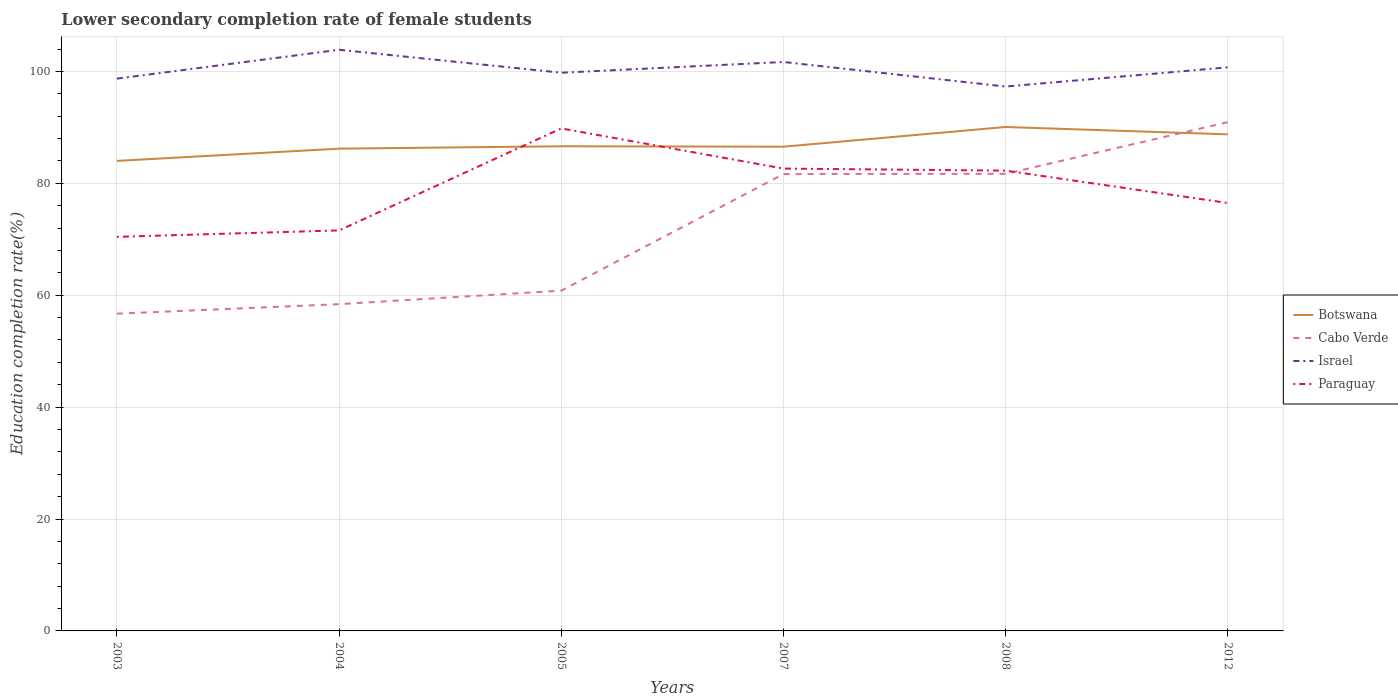How many different coloured lines are there?
Make the answer very short. 4. Does the line corresponding to Paraguay intersect with the line corresponding to Botswana?
Give a very brief answer. Yes. Across all years, what is the maximum lower secondary completion rate of female students in Cabo Verde?
Your answer should be compact. 56.7. What is the total lower secondary completion rate of female students in Botswana in the graph?
Offer a terse response. 1.32. What is the difference between the highest and the second highest lower secondary completion rate of female students in Paraguay?
Keep it short and to the point. 19.38. What is the difference between the highest and the lowest lower secondary completion rate of female students in Cabo Verde?
Offer a terse response. 3. Is the lower secondary completion rate of female students in Israel strictly greater than the lower secondary completion rate of female students in Cabo Verde over the years?
Offer a very short reply. No. How many lines are there?
Ensure brevity in your answer.  4. How many years are there in the graph?
Offer a very short reply. 6. Does the graph contain any zero values?
Ensure brevity in your answer.  No. Does the graph contain grids?
Provide a short and direct response. Yes. What is the title of the graph?
Provide a succinct answer. Lower secondary completion rate of female students. Does "Angola" appear as one of the legend labels in the graph?
Provide a succinct answer. No. What is the label or title of the Y-axis?
Provide a short and direct response. Education completion rate(%). What is the Education completion rate(%) in Botswana in 2003?
Your response must be concise. 84.01. What is the Education completion rate(%) in Cabo Verde in 2003?
Offer a very short reply. 56.7. What is the Education completion rate(%) of Israel in 2003?
Make the answer very short. 98.71. What is the Education completion rate(%) of Paraguay in 2003?
Your answer should be very brief. 70.43. What is the Education completion rate(%) in Botswana in 2004?
Ensure brevity in your answer.  86.19. What is the Education completion rate(%) in Cabo Verde in 2004?
Offer a very short reply. 58.4. What is the Education completion rate(%) in Israel in 2004?
Offer a terse response. 103.87. What is the Education completion rate(%) in Paraguay in 2004?
Provide a succinct answer. 71.58. What is the Education completion rate(%) of Botswana in 2005?
Your answer should be very brief. 86.62. What is the Education completion rate(%) of Cabo Verde in 2005?
Your response must be concise. 60.82. What is the Education completion rate(%) of Israel in 2005?
Offer a terse response. 99.77. What is the Education completion rate(%) of Paraguay in 2005?
Provide a short and direct response. 89.81. What is the Education completion rate(%) in Botswana in 2007?
Provide a short and direct response. 86.54. What is the Education completion rate(%) in Cabo Verde in 2007?
Keep it short and to the point. 81.65. What is the Education completion rate(%) in Israel in 2007?
Your response must be concise. 101.68. What is the Education completion rate(%) of Paraguay in 2007?
Give a very brief answer. 82.63. What is the Education completion rate(%) of Botswana in 2008?
Offer a terse response. 90.06. What is the Education completion rate(%) of Cabo Verde in 2008?
Make the answer very short. 81.7. What is the Education completion rate(%) of Israel in 2008?
Your answer should be very brief. 97.29. What is the Education completion rate(%) in Paraguay in 2008?
Offer a terse response. 82.26. What is the Education completion rate(%) in Botswana in 2012?
Provide a succinct answer. 88.75. What is the Education completion rate(%) of Cabo Verde in 2012?
Keep it short and to the point. 90.93. What is the Education completion rate(%) in Israel in 2012?
Keep it short and to the point. 100.73. What is the Education completion rate(%) of Paraguay in 2012?
Your response must be concise. 76.48. Across all years, what is the maximum Education completion rate(%) in Botswana?
Offer a terse response. 90.06. Across all years, what is the maximum Education completion rate(%) of Cabo Verde?
Give a very brief answer. 90.93. Across all years, what is the maximum Education completion rate(%) in Israel?
Keep it short and to the point. 103.87. Across all years, what is the maximum Education completion rate(%) in Paraguay?
Offer a terse response. 89.81. Across all years, what is the minimum Education completion rate(%) in Botswana?
Your response must be concise. 84.01. Across all years, what is the minimum Education completion rate(%) of Cabo Verde?
Provide a short and direct response. 56.7. Across all years, what is the minimum Education completion rate(%) in Israel?
Give a very brief answer. 97.29. Across all years, what is the minimum Education completion rate(%) in Paraguay?
Offer a very short reply. 70.43. What is the total Education completion rate(%) of Botswana in the graph?
Give a very brief answer. 522.17. What is the total Education completion rate(%) in Cabo Verde in the graph?
Your answer should be compact. 430.19. What is the total Education completion rate(%) of Israel in the graph?
Your answer should be compact. 602.05. What is the total Education completion rate(%) in Paraguay in the graph?
Your response must be concise. 473.21. What is the difference between the Education completion rate(%) in Botswana in 2003 and that in 2004?
Make the answer very short. -2.19. What is the difference between the Education completion rate(%) of Cabo Verde in 2003 and that in 2004?
Make the answer very short. -1.7. What is the difference between the Education completion rate(%) in Israel in 2003 and that in 2004?
Offer a terse response. -5.16. What is the difference between the Education completion rate(%) of Paraguay in 2003 and that in 2004?
Offer a very short reply. -1.15. What is the difference between the Education completion rate(%) in Botswana in 2003 and that in 2005?
Your answer should be very brief. -2.62. What is the difference between the Education completion rate(%) of Cabo Verde in 2003 and that in 2005?
Offer a terse response. -4.12. What is the difference between the Education completion rate(%) in Israel in 2003 and that in 2005?
Your answer should be very brief. -1.05. What is the difference between the Education completion rate(%) in Paraguay in 2003 and that in 2005?
Your answer should be compact. -19.38. What is the difference between the Education completion rate(%) of Botswana in 2003 and that in 2007?
Keep it short and to the point. -2.54. What is the difference between the Education completion rate(%) in Cabo Verde in 2003 and that in 2007?
Keep it short and to the point. -24.95. What is the difference between the Education completion rate(%) of Israel in 2003 and that in 2007?
Offer a terse response. -2.97. What is the difference between the Education completion rate(%) of Paraguay in 2003 and that in 2007?
Your answer should be compact. -12.2. What is the difference between the Education completion rate(%) of Botswana in 2003 and that in 2008?
Give a very brief answer. -6.06. What is the difference between the Education completion rate(%) in Cabo Verde in 2003 and that in 2008?
Your response must be concise. -25. What is the difference between the Education completion rate(%) of Israel in 2003 and that in 2008?
Keep it short and to the point. 1.42. What is the difference between the Education completion rate(%) in Paraguay in 2003 and that in 2008?
Offer a terse response. -11.83. What is the difference between the Education completion rate(%) in Botswana in 2003 and that in 2012?
Your response must be concise. -4.74. What is the difference between the Education completion rate(%) in Cabo Verde in 2003 and that in 2012?
Offer a terse response. -34.23. What is the difference between the Education completion rate(%) in Israel in 2003 and that in 2012?
Offer a very short reply. -2.02. What is the difference between the Education completion rate(%) in Paraguay in 2003 and that in 2012?
Your answer should be compact. -6.05. What is the difference between the Education completion rate(%) of Botswana in 2004 and that in 2005?
Keep it short and to the point. -0.43. What is the difference between the Education completion rate(%) in Cabo Verde in 2004 and that in 2005?
Offer a very short reply. -2.42. What is the difference between the Education completion rate(%) of Israel in 2004 and that in 2005?
Your answer should be compact. 4.1. What is the difference between the Education completion rate(%) of Paraguay in 2004 and that in 2005?
Your answer should be very brief. -18.23. What is the difference between the Education completion rate(%) of Botswana in 2004 and that in 2007?
Your response must be concise. -0.35. What is the difference between the Education completion rate(%) in Cabo Verde in 2004 and that in 2007?
Keep it short and to the point. -23.25. What is the difference between the Education completion rate(%) in Israel in 2004 and that in 2007?
Provide a short and direct response. 2.18. What is the difference between the Education completion rate(%) of Paraguay in 2004 and that in 2007?
Give a very brief answer. -11.05. What is the difference between the Education completion rate(%) of Botswana in 2004 and that in 2008?
Make the answer very short. -3.87. What is the difference between the Education completion rate(%) in Cabo Verde in 2004 and that in 2008?
Provide a short and direct response. -23.3. What is the difference between the Education completion rate(%) in Israel in 2004 and that in 2008?
Keep it short and to the point. 6.57. What is the difference between the Education completion rate(%) in Paraguay in 2004 and that in 2008?
Your response must be concise. -10.68. What is the difference between the Education completion rate(%) in Botswana in 2004 and that in 2012?
Ensure brevity in your answer.  -2.55. What is the difference between the Education completion rate(%) of Cabo Verde in 2004 and that in 2012?
Offer a very short reply. -32.53. What is the difference between the Education completion rate(%) of Israel in 2004 and that in 2012?
Offer a terse response. 3.14. What is the difference between the Education completion rate(%) in Paraguay in 2004 and that in 2012?
Your answer should be compact. -4.9. What is the difference between the Education completion rate(%) in Botswana in 2005 and that in 2007?
Offer a very short reply. 0.08. What is the difference between the Education completion rate(%) of Cabo Verde in 2005 and that in 2007?
Ensure brevity in your answer.  -20.83. What is the difference between the Education completion rate(%) in Israel in 2005 and that in 2007?
Make the answer very short. -1.92. What is the difference between the Education completion rate(%) in Paraguay in 2005 and that in 2007?
Provide a succinct answer. 7.18. What is the difference between the Education completion rate(%) of Botswana in 2005 and that in 2008?
Your answer should be very brief. -3.44. What is the difference between the Education completion rate(%) in Cabo Verde in 2005 and that in 2008?
Keep it short and to the point. -20.88. What is the difference between the Education completion rate(%) of Israel in 2005 and that in 2008?
Offer a terse response. 2.47. What is the difference between the Education completion rate(%) in Paraguay in 2005 and that in 2008?
Make the answer very short. 7.55. What is the difference between the Education completion rate(%) in Botswana in 2005 and that in 2012?
Make the answer very short. -2.13. What is the difference between the Education completion rate(%) of Cabo Verde in 2005 and that in 2012?
Your response must be concise. -30.11. What is the difference between the Education completion rate(%) in Israel in 2005 and that in 2012?
Give a very brief answer. -0.96. What is the difference between the Education completion rate(%) of Paraguay in 2005 and that in 2012?
Your response must be concise. 13.33. What is the difference between the Education completion rate(%) of Botswana in 2007 and that in 2008?
Provide a short and direct response. -3.52. What is the difference between the Education completion rate(%) in Cabo Verde in 2007 and that in 2008?
Ensure brevity in your answer.  -0.05. What is the difference between the Education completion rate(%) of Israel in 2007 and that in 2008?
Keep it short and to the point. 4.39. What is the difference between the Education completion rate(%) of Paraguay in 2007 and that in 2008?
Your answer should be very brief. 0.37. What is the difference between the Education completion rate(%) in Botswana in 2007 and that in 2012?
Keep it short and to the point. -2.21. What is the difference between the Education completion rate(%) of Cabo Verde in 2007 and that in 2012?
Offer a very short reply. -9.28. What is the difference between the Education completion rate(%) in Israel in 2007 and that in 2012?
Ensure brevity in your answer.  0.95. What is the difference between the Education completion rate(%) of Paraguay in 2007 and that in 2012?
Keep it short and to the point. 6.15. What is the difference between the Education completion rate(%) in Botswana in 2008 and that in 2012?
Keep it short and to the point. 1.32. What is the difference between the Education completion rate(%) in Cabo Verde in 2008 and that in 2012?
Offer a terse response. -9.23. What is the difference between the Education completion rate(%) of Israel in 2008 and that in 2012?
Provide a short and direct response. -3.43. What is the difference between the Education completion rate(%) of Paraguay in 2008 and that in 2012?
Offer a very short reply. 5.78. What is the difference between the Education completion rate(%) of Botswana in 2003 and the Education completion rate(%) of Cabo Verde in 2004?
Provide a succinct answer. 25.6. What is the difference between the Education completion rate(%) of Botswana in 2003 and the Education completion rate(%) of Israel in 2004?
Ensure brevity in your answer.  -19.86. What is the difference between the Education completion rate(%) of Botswana in 2003 and the Education completion rate(%) of Paraguay in 2004?
Your answer should be very brief. 12.43. What is the difference between the Education completion rate(%) of Cabo Verde in 2003 and the Education completion rate(%) of Israel in 2004?
Offer a terse response. -47.17. What is the difference between the Education completion rate(%) of Cabo Verde in 2003 and the Education completion rate(%) of Paraguay in 2004?
Your response must be concise. -14.88. What is the difference between the Education completion rate(%) in Israel in 2003 and the Education completion rate(%) in Paraguay in 2004?
Offer a very short reply. 27.13. What is the difference between the Education completion rate(%) in Botswana in 2003 and the Education completion rate(%) in Cabo Verde in 2005?
Provide a short and direct response. 23.19. What is the difference between the Education completion rate(%) in Botswana in 2003 and the Education completion rate(%) in Israel in 2005?
Provide a short and direct response. -15.76. What is the difference between the Education completion rate(%) in Botswana in 2003 and the Education completion rate(%) in Paraguay in 2005?
Make the answer very short. -5.81. What is the difference between the Education completion rate(%) of Cabo Verde in 2003 and the Education completion rate(%) of Israel in 2005?
Offer a terse response. -43.07. What is the difference between the Education completion rate(%) in Cabo Verde in 2003 and the Education completion rate(%) in Paraguay in 2005?
Keep it short and to the point. -33.11. What is the difference between the Education completion rate(%) of Israel in 2003 and the Education completion rate(%) of Paraguay in 2005?
Your answer should be compact. 8.9. What is the difference between the Education completion rate(%) in Botswana in 2003 and the Education completion rate(%) in Cabo Verde in 2007?
Give a very brief answer. 2.36. What is the difference between the Education completion rate(%) in Botswana in 2003 and the Education completion rate(%) in Israel in 2007?
Your response must be concise. -17.68. What is the difference between the Education completion rate(%) in Botswana in 2003 and the Education completion rate(%) in Paraguay in 2007?
Offer a terse response. 1.37. What is the difference between the Education completion rate(%) in Cabo Verde in 2003 and the Education completion rate(%) in Israel in 2007?
Provide a succinct answer. -44.98. What is the difference between the Education completion rate(%) in Cabo Verde in 2003 and the Education completion rate(%) in Paraguay in 2007?
Your response must be concise. -25.93. What is the difference between the Education completion rate(%) in Israel in 2003 and the Education completion rate(%) in Paraguay in 2007?
Make the answer very short. 16.08. What is the difference between the Education completion rate(%) of Botswana in 2003 and the Education completion rate(%) of Cabo Verde in 2008?
Your response must be concise. 2.31. What is the difference between the Education completion rate(%) of Botswana in 2003 and the Education completion rate(%) of Israel in 2008?
Your response must be concise. -13.29. What is the difference between the Education completion rate(%) of Botswana in 2003 and the Education completion rate(%) of Paraguay in 2008?
Provide a succinct answer. 1.74. What is the difference between the Education completion rate(%) of Cabo Verde in 2003 and the Education completion rate(%) of Israel in 2008?
Make the answer very short. -40.59. What is the difference between the Education completion rate(%) in Cabo Verde in 2003 and the Education completion rate(%) in Paraguay in 2008?
Your answer should be very brief. -25.56. What is the difference between the Education completion rate(%) of Israel in 2003 and the Education completion rate(%) of Paraguay in 2008?
Offer a very short reply. 16.45. What is the difference between the Education completion rate(%) of Botswana in 2003 and the Education completion rate(%) of Cabo Verde in 2012?
Make the answer very short. -6.92. What is the difference between the Education completion rate(%) in Botswana in 2003 and the Education completion rate(%) in Israel in 2012?
Provide a short and direct response. -16.72. What is the difference between the Education completion rate(%) of Botswana in 2003 and the Education completion rate(%) of Paraguay in 2012?
Your response must be concise. 7.52. What is the difference between the Education completion rate(%) in Cabo Verde in 2003 and the Education completion rate(%) in Israel in 2012?
Offer a very short reply. -44.03. What is the difference between the Education completion rate(%) of Cabo Verde in 2003 and the Education completion rate(%) of Paraguay in 2012?
Your answer should be compact. -19.78. What is the difference between the Education completion rate(%) of Israel in 2003 and the Education completion rate(%) of Paraguay in 2012?
Make the answer very short. 22.23. What is the difference between the Education completion rate(%) of Botswana in 2004 and the Education completion rate(%) of Cabo Verde in 2005?
Offer a terse response. 25.37. What is the difference between the Education completion rate(%) of Botswana in 2004 and the Education completion rate(%) of Israel in 2005?
Make the answer very short. -13.57. What is the difference between the Education completion rate(%) of Botswana in 2004 and the Education completion rate(%) of Paraguay in 2005?
Make the answer very short. -3.62. What is the difference between the Education completion rate(%) of Cabo Verde in 2004 and the Education completion rate(%) of Israel in 2005?
Your answer should be compact. -41.36. What is the difference between the Education completion rate(%) of Cabo Verde in 2004 and the Education completion rate(%) of Paraguay in 2005?
Provide a short and direct response. -31.41. What is the difference between the Education completion rate(%) in Israel in 2004 and the Education completion rate(%) in Paraguay in 2005?
Provide a short and direct response. 14.05. What is the difference between the Education completion rate(%) of Botswana in 2004 and the Education completion rate(%) of Cabo Verde in 2007?
Your answer should be compact. 4.54. What is the difference between the Education completion rate(%) of Botswana in 2004 and the Education completion rate(%) of Israel in 2007?
Offer a very short reply. -15.49. What is the difference between the Education completion rate(%) of Botswana in 2004 and the Education completion rate(%) of Paraguay in 2007?
Offer a terse response. 3.56. What is the difference between the Education completion rate(%) of Cabo Verde in 2004 and the Education completion rate(%) of Israel in 2007?
Keep it short and to the point. -43.28. What is the difference between the Education completion rate(%) in Cabo Verde in 2004 and the Education completion rate(%) in Paraguay in 2007?
Give a very brief answer. -24.23. What is the difference between the Education completion rate(%) of Israel in 2004 and the Education completion rate(%) of Paraguay in 2007?
Provide a succinct answer. 21.23. What is the difference between the Education completion rate(%) in Botswana in 2004 and the Education completion rate(%) in Cabo Verde in 2008?
Ensure brevity in your answer.  4.5. What is the difference between the Education completion rate(%) in Botswana in 2004 and the Education completion rate(%) in Paraguay in 2008?
Offer a very short reply. 3.93. What is the difference between the Education completion rate(%) of Cabo Verde in 2004 and the Education completion rate(%) of Israel in 2008?
Your response must be concise. -38.89. What is the difference between the Education completion rate(%) of Cabo Verde in 2004 and the Education completion rate(%) of Paraguay in 2008?
Your answer should be very brief. -23.86. What is the difference between the Education completion rate(%) in Israel in 2004 and the Education completion rate(%) in Paraguay in 2008?
Keep it short and to the point. 21.6. What is the difference between the Education completion rate(%) of Botswana in 2004 and the Education completion rate(%) of Cabo Verde in 2012?
Make the answer very short. -4.73. What is the difference between the Education completion rate(%) of Botswana in 2004 and the Education completion rate(%) of Israel in 2012?
Ensure brevity in your answer.  -14.53. What is the difference between the Education completion rate(%) of Botswana in 2004 and the Education completion rate(%) of Paraguay in 2012?
Keep it short and to the point. 9.71. What is the difference between the Education completion rate(%) in Cabo Verde in 2004 and the Education completion rate(%) in Israel in 2012?
Your response must be concise. -42.33. What is the difference between the Education completion rate(%) of Cabo Verde in 2004 and the Education completion rate(%) of Paraguay in 2012?
Ensure brevity in your answer.  -18.08. What is the difference between the Education completion rate(%) of Israel in 2004 and the Education completion rate(%) of Paraguay in 2012?
Ensure brevity in your answer.  27.38. What is the difference between the Education completion rate(%) of Botswana in 2005 and the Education completion rate(%) of Cabo Verde in 2007?
Provide a succinct answer. 4.97. What is the difference between the Education completion rate(%) of Botswana in 2005 and the Education completion rate(%) of Israel in 2007?
Your answer should be very brief. -15.06. What is the difference between the Education completion rate(%) of Botswana in 2005 and the Education completion rate(%) of Paraguay in 2007?
Provide a succinct answer. 3.99. What is the difference between the Education completion rate(%) in Cabo Verde in 2005 and the Education completion rate(%) in Israel in 2007?
Provide a succinct answer. -40.86. What is the difference between the Education completion rate(%) in Cabo Verde in 2005 and the Education completion rate(%) in Paraguay in 2007?
Provide a succinct answer. -21.81. What is the difference between the Education completion rate(%) in Israel in 2005 and the Education completion rate(%) in Paraguay in 2007?
Make the answer very short. 17.13. What is the difference between the Education completion rate(%) in Botswana in 2005 and the Education completion rate(%) in Cabo Verde in 2008?
Keep it short and to the point. 4.92. What is the difference between the Education completion rate(%) in Botswana in 2005 and the Education completion rate(%) in Israel in 2008?
Your answer should be compact. -10.67. What is the difference between the Education completion rate(%) in Botswana in 2005 and the Education completion rate(%) in Paraguay in 2008?
Your answer should be very brief. 4.36. What is the difference between the Education completion rate(%) in Cabo Verde in 2005 and the Education completion rate(%) in Israel in 2008?
Offer a terse response. -36.47. What is the difference between the Education completion rate(%) in Cabo Verde in 2005 and the Education completion rate(%) in Paraguay in 2008?
Offer a very short reply. -21.44. What is the difference between the Education completion rate(%) in Israel in 2005 and the Education completion rate(%) in Paraguay in 2008?
Give a very brief answer. 17.5. What is the difference between the Education completion rate(%) in Botswana in 2005 and the Education completion rate(%) in Cabo Verde in 2012?
Offer a very short reply. -4.31. What is the difference between the Education completion rate(%) of Botswana in 2005 and the Education completion rate(%) of Israel in 2012?
Make the answer very short. -14.11. What is the difference between the Education completion rate(%) in Botswana in 2005 and the Education completion rate(%) in Paraguay in 2012?
Give a very brief answer. 10.14. What is the difference between the Education completion rate(%) in Cabo Verde in 2005 and the Education completion rate(%) in Israel in 2012?
Your response must be concise. -39.91. What is the difference between the Education completion rate(%) in Cabo Verde in 2005 and the Education completion rate(%) in Paraguay in 2012?
Give a very brief answer. -15.66. What is the difference between the Education completion rate(%) of Israel in 2005 and the Education completion rate(%) of Paraguay in 2012?
Offer a very short reply. 23.28. What is the difference between the Education completion rate(%) in Botswana in 2007 and the Education completion rate(%) in Cabo Verde in 2008?
Make the answer very short. 4.84. What is the difference between the Education completion rate(%) of Botswana in 2007 and the Education completion rate(%) of Israel in 2008?
Offer a terse response. -10.75. What is the difference between the Education completion rate(%) in Botswana in 2007 and the Education completion rate(%) in Paraguay in 2008?
Your response must be concise. 4.28. What is the difference between the Education completion rate(%) in Cabo Verde in 2007 and the Education completion rate(%) in Israel in 2008?
Provide a succinct answer. -15.64. What is the difference between the Education completion rate(%) in Cabo Verde in 2007 and the Education completion rate(%) in Paraguay in 2008?
Offer a very short reply. -0.62. What is the difference between the Education completion rate(%) in Israel in 2007 and the Education completion rate(%) in Paraguay in 2008?
Make the answer very short. 19.42. What is the difference between the Education completion rate(%) of Botswana in 2007 and the Education completion rate(%) of Cabo Verde in 2012?
Your answer should be compact. -4.39. What is the difference between the Education completion rate(%) of Botswana in 2007 and the Education completion rate(%) of Israel in 2012?
Give a very brief answer. -14.19. What is the difference between the Education completion rate(%) of Botswana in 2007 and the Education completion rate(%) of Paraguay in 2012?
Give a very brief answer. 10.06. What is the difference between the Education completion rate(%) in Cabo Verde in 2007 and the Education completion rate(%) in Israel in 2012?
Provide a succinct answer. -19.08. What is the difference between the Education completion rate(%) in Cabo Verde in 2007 and the Education completion rate(%) in Paraguay in 2012?
Your answer should be very brief. 5.17. What is the difference between the Education completion rate(%) of Israel in 2007 and the Education completion rate(%) of Paraguay in 2012?
Ensure brevity in your answer.  25.2. What is the difference between the Education completion rate(%) of Botswana in 2008 and the Education completion rate(%) of Cabo Verde in 2012?
Offer a very short reply. -0.86. What is the difference between the Education completion rate(%) of Botswana in 2008 and the Education completion rate(%) of Israel in 2012?
Your response must be concise. -10.66. What is the difference between the Education completion rate(%) in Botswana in 2008 and the Education completion rate(%) in Paraguay in 2012?
Give a very brief answer. 13.58. What is the difference between the Education completion rate(%) of Cabo Verde in 2008 and the Education completion rate(%) of Israel in 2012?
Your answer should be compact. -19.03. What is the difference between the Education completion rate(%) in Cabo Verde in 2008 and the Education completion rate(%) in Paraguay in 2012?
Your answer should be very brief. 5.22. What is the difference between the Education completion rate(%) in Israel in 2008 and the Education completion rate(%) in Paraguay in 2012?
Make the answer very short. 20.81. What is the average Education completion rate(%) of Botswana per year?
Make the answer very short. 87.03. What is the average Education completion rate(%) of Cabo Verde per year?
Offer a very short reply. 71.7. What is the average Education completion rate(%) in Israel per year?
Keep it short and to the point. 100.34. What is the average Education completion rate(%) of Paraguay per year?
Provide a succinct answer. 78.87. In the year 2003, what is the difference between the Education completion rate(%) in Botswana and Education completion rate(%) in Cabo Verde?
Provide a short and direct response. 27.31. In the year 2003, what is the difference between the Education completion rate(%) of Botswana and Education completion rate(%) of Israel?
Provide a short and direct response. -14.71. In the year 2003, what is the difference between the Education completion rate(%) of Botswana and Education completion rate(%) of Paraguay?
Keep it short and to the point. 13.57. In the year 2003, what is the difference between the Education completion rate(%) of Cabo Verde and Education completion rate(%) of Israel?
Your answer should be compact. -42.01. In the year 2003, what is the difference between the Education completion rate(%) of Cabo Verde and Education completion rate(%) of Paraguay?
Offer a very short reply. -13.73. In the year 2003, what is the difference between the Education completion rate(%) of Israel and Education completion rate(%) of Paraguay?
Ensure brevity in your answer.  28.28. In the year 2004, what is the difference between the Education completion rate(%) of Botswana and Education completion rate(%) of Cabo Verde?
Keep it short and to the point. 27.79. In the year 2004, what is the difference between the Education completion rate(%) of Botswana and Education completion rate(%) of Israel?
Your answer should be compact. -17.67. In the year 2004, what is the difference between the Education completion rate(%) in Botswana and Education completion rate(%) in Paraguay?
Keep it short and to the point. 14.61. In the year 2004, what is the difference between the Education completion rate(%) in Cabo Verde and Education completion rate(%) in Israel?
Provide a short and direct response. -45.46. In the year 2004, what is the difference between the Education completion rate(%) in Cabo Verde and Education completion rate(%) in Paraguay?
Make the answer very short. -13.18. In the year 2004, what is the difference between the Education completion rate(%) of Israel and Education completion rate(%) of Paraguay?
Your answer should be compact. 32.29. In the year 2005, what is the difference between the Education completion rate(%) in Botswana and Education completion rate(%) in Cabo Verde?
Provide a succinct answer. 25.8. In the year 2005, what is the difference between the Education completion rate(%) of Botswana and Education completion rate(%) of Israel?
Ensure brevity in your answer.  -13.14. In the year 2005, what is the difference between the Education completion rate(%) in Botswana and Education completion rate(%) in Paraguay?
Your answer should be very brief. -3.19. In the year 2005, what is the difference between the Education completion rate(%) in Cabo Verde and Education completion rate(%) in Israel?
Ensure brevity in your answer.  -38.95. In the year 2005, what is the difference between the Education completion rate(%) in Cabo Verde and Education completion rate(%) in Paraguay?
Your answer should be very brief. -28.99. In the year 2005, what is the difference between the Education completion rate(%) in Israel and Education completion rate(%) in Paraguay?
Make the answer very short. 9.95. In the year 2007, what is the difference between the Education completion rate(%) of Botswana and Education completion rate(%) of Cabo Verde?
Your answer should be compact. 4.89. In the year 2007, what is the difference between the Education completion rate(%) in Botswana and Education completion rate(%) in Israel?
Your answer should be compact. -15.14. In the year 2007, what is the difference between the Education completion rate(%) in Botswana and Education completion rate(%) in Paraguay?
Your answer should be very brief. 3.91. In the year 2007, what is the difference between the Education completion rate(%) of Cabo Verde and Education completion rate(%) of Israel?
Your answer should be compact. -20.03. In the year 2007, what is the difference between the Education completion rate(%) in Cabo Verde and Education completion rate(%) in Paraguay?
Your answer should be compact. -0.98. In the year 2007, what is the difference between the Education completion rate(%) of Israel and Education completion rate(%) of Paraguay?
Make the answer very short. 19.05. In the year 2008, what is the difference between the Education completion rate(%) in Botswana and Education completion rate(%) in Cabo Verde?
Keep it short and to the point. 8.37. In the year 2008, what is the difference between the Education completion rate(%) in Botswana and Education completion rate(%) in Israel?
Your answer should be compact. -7.23. In the year 2008, what is the difference between the Education completion rate(%) in Botswana and Education completion rate(%) in Paraguay?
Make the answer very short. 7.8. In the year 2008, what is the difference between the Education completion rate(%) in Cabo Verde and Education completion rate(%) in Israel?
Offer a very short reply. -15.6. In the year 2008, what is the difference between the Education completion rate(%) of Cabo Verde and Education completion rate(%) of Paraguay?
Offer a terse response. -0.57. In the year 2008, what is the difference between the Education completion rate(%) of Israel and Education completion rate(%) of Paraguay?
Offer a terse response. 15.03. In the year 2012, what is the difference between the Education completion rate(%) in Botswana and Education completion rate(%) in Cabo Verde?
Ensure brevity in your answer.  -2.18. In the year 2012, what is the difference between the Education completion rate(%) in Botswana and Education completion rate(%) in Israel?
Offer a very short reply. -11.98. In the year 2012, what is the difference between the Education completion rate(%) in Botswana and Education completion rate(%) in Paraguay?
Offer a very short reply. 12.27. In the year 2012, what is the difference between the Education completion rate(%) in Cabo Verde and Education completion rate(%) in Israel?
Offer a terse response. -9.8. In the year 2012, what is the difference between the Education completion rate(%) in Cabo Verde and Education completion rate(%) in Paraguay?
Offer a very short reply. 14.45. In the year 2012, what is the difference between the Education completion rate(%) of Israel and Education completion rate(%) of Paraguay?
Keep it short and to the point. 24.25. What is the ratio of the Education completion rate(%) of Botswana in 2003 to that in 2004?
Provide a succinct answer. 0.97. What is the ratio of the Education completion rate(%) of Cabo Verde in 2003 to that in 2004?
Offer a very short reply. 0.97. What is the ratio of the Education completion rate(%) in Israel in 2003 to that in 2004?
Offer a very short reply. 0.95. What is the ratio of the Education completion rate(%) in Paraguay in 2003 to that in 2004?
Give a very brief answer. 0.98. What is the ratio of the Education completion rate(%) of Botswana in 2003 to that in 2005?
Your response must be concise. 0.97. What is the ratio of the Education completion rate(%) of Cabo Verde in 2003 to that in 2005?
Your answer should be very brief. 0.93. What is the ratio of the Education completion rate(%) of Paraguay in 2003 to that in 2005?
Give a very brief answer. 0.78. What is the ratio of the Education completion rate(%) of Botswana in 2003 to that in 2007?
Provide a short and direct response. 0.97. What is the ratio of the Education completion rate(%) of Cabo Verde in 2003 to that in 2007?
Your answer should be very brief. 0.69. What is the ratio of the Education completion rate(%) in Israel in 2003 to that in 2007?
Provide a short and direct response. 0.97. What is the ratio of the Education completion rate(%) in Paraguay in 2003 to that in 2007?
Provide a short and direct response. 0.85. What is the ratio of the Education completion rate(%) of Botswana in 2003 to that in 2008?
Give a very brief answer. 0.93. What is the ratio of the Education completion rate(%) in Cabo Verde in 2003 to that in 2008?
Your answer should be compact. 0.69. What is the ratio of the Education completion rate(%) in Israel in 2003 to that in 2008?
Provide a short and direct response. 1.01. What is the ratio of the Education completion rate(%) in Paraguay in 2003 to that in 2008?
Keep it short and to the point. 0.86. What is the ratio of the Education completion rate(%) in Botswana in 2003 to that in 2012?
Keep it short and to the point. 0.95. What is the ratio of the Education completion rate(%) of Cabo Verde in 2003 to that in 2012?
Keep it short and to the point. 0.62. What is the ratio of the Education completion rate(%) in Paraguay in 2003 to that in 2012?
Provide a succinct answer. 0.92. What is the ratio of the Education completion rate(%) of Cabo Verde in 2004 to that in 2005?
Provide a short and direct response. 0.96. What is the ratio of the Education completion rate(%) in Israel in 2004 to that in 2005?
Ensure brevity in your answer.  1.04. What is the ratio of the Education completion rate(%) of Paraguay in 2004 to that in 2005?
Give a very brief answer. 0.8. What is the ratio of the Education completion rate(%) in Botswana in 2004 to that in 2007?
Your answer should be compact. 1. What is the ratio of the Education completion rate(%) in Cabo Verde in 2004 to that in 2007?
Keep it short and to the point. 0.72. What is the ratio of the Education completion rate(%) of Israel in 2004 to that in 2007?
Offer a very short reply. 1.02. What is the ratio of the Education completion rate(%) of Paraguay in 2004 to that in 2007?
Your response must be concise. 0.87. What is the ratio of the Education completion rate(%) of Cabo Verde in 2004 to that in 2008?
Your response must be concise. 0.71. What is the ratio of the Education completion rate(%) in Israel in 2004 to that in 2008?
Provide a short and direct response. 1.07. What is the ratio of the Education completion rate(%) in Paraguay in 2004 to that in 2008?
Offer a terse response. 0.87. What is the ratio of the Education completion rate(%) in Botswana in 2004 to that in 2012?
Offer a very short reply. 0.97. What is the ratio of the Education completion rate(%) of Cabo Verde in 2004 to that in 2012?
Offer a terse response. 0.64. What is the ratio of the Education completion rate(%) of Israel in 2004 to that in 2012?
Your response must be concise. 1.03. What is the ratio of the Education completion rate(%) in Paraguay in 2004 to that in 2012?
Offer a very short reply. 0.94. What is the ratio of the Education completion rate(%) in Botswana in 2005 to that in 2007?
Offer a terse response. 1. What is the ratio of the Education completion rate(%) in Cabo Verde in 2005 to that in 2007?
Give a very brief answer. 0.74. What is the ratio of the Education completion rate(%) in Israel in 2005 to that in 2007?
Make the answer very short. 0.98. What is the ratio of the Education completion rate(%) in Paraguay in 2005 to that in 2007?
Offer a very short reply. 1.09. What is the ratio of the Education completion rate(%) in Botswana in 2005 to that in 2008?
Give a very brief answer. 0.96. What is the ratio of the Education completion rate(%) in Cabo Verde in 2005 to that in 2008?
Provide a succinct answer. 0.74. What is the ratio of the Education completion rate(%) in Israel in 2005 to that in 2008?
Give a very brief answer. 1.03. What is the ratio of the Education completion rate(%) of Paraguay in 2005 to that in 2008?
Provide a short and direct response. 1.09. What is the ratio of the Education completion rate(%) of Botswana in 2005 to that in 2012?
Provide a short and direct response. 0.98. What is the ratio of the Education completion rate(%) in Cabo Verde in 2005 to that in 2012?
Offer a terse response. 0.67. What is the ratio of the Education completion rate(%) of Israel in 2005 to that in 2012?
Give a very brief answer. 0.99. What is the ratio of the Education completion rate(%) in Paraguay in 2005 to that in 2012?
Provide a short and direct response. 1.17. What is the ratio of the Education completion rate(%) in Botswana in 2007 to that in 2008?
Offer a very short reply. 0.96. What is the ratio of the Education completion rate(%) of Israel in 2007 to that in 2008?
Keep it short and to the point. 1.05. What is the ratio of the Education completion rate(%) in Botswana in 2007 to that in 2012?
Offer a terse response. 0.98. What is the ratio of the Education completion rate(%) of Cabo Verde in 2007 to that in 2012?
Give a very brief answer. 0.9. What is the ratio of the Education completion rate(%) in Israel in 2007 to that in 2012?
Your answer should be very brief. 1.01. What is the ratio of the Education completion rate(%) of Paraguay in 2007 to that in 2012?
Offer a terse response. 1.08. What is the ratio of the Education completion rate(%) of Botswana in 2008 to that in 2012?
Offer a very short reply. 1.01. What is the ratio of the Education completion rate(%) in Cabo Verde in 2008 to that in 2012?
Your response must be concise. 0.9. What is the ratio of the Education completion rate(%) in Israel in 2008 to that in 2012?
Give a very brief answer. 0.97. What is the ratio of the Education completion rate(%) in Paraguay in 2008 to that in 2012?
Make the answer very short. 1.08. What is the difference between the highest and the second highest Education completion rate(%) of Botswana?
Provide a succinct answer. 1.32. What is the difference between the highest and the second highest Education completion rate(%) of Cabo Verde?
Provide a short and direct response. 9.23. What is the difference between the highest and the second highest Education completion rate(%) of Israel?
Offer a very short reply. 2.18. What is the difference between the highest and the second highest Education completion rate(%) of Paraguay?
Ensure brevity in your answer.  7.18. What is the difference between the highest and the lowest Education completion rate(%) in Botswana?
Keep it short and to the point. 6.06. What is the difference between the highest and the lowest Education completion rate(%) in Cabo Verde?
Your response must be concise. 34.23. What is the difference between the highest and the lowest Education completion rate(%) in Israel?
Ensure brevity in your answer.  6.57. What is the difference between the highest and the lowest Education completion rate(%) of Paraguay?
Ensure brevity in your answer.  19.38. 